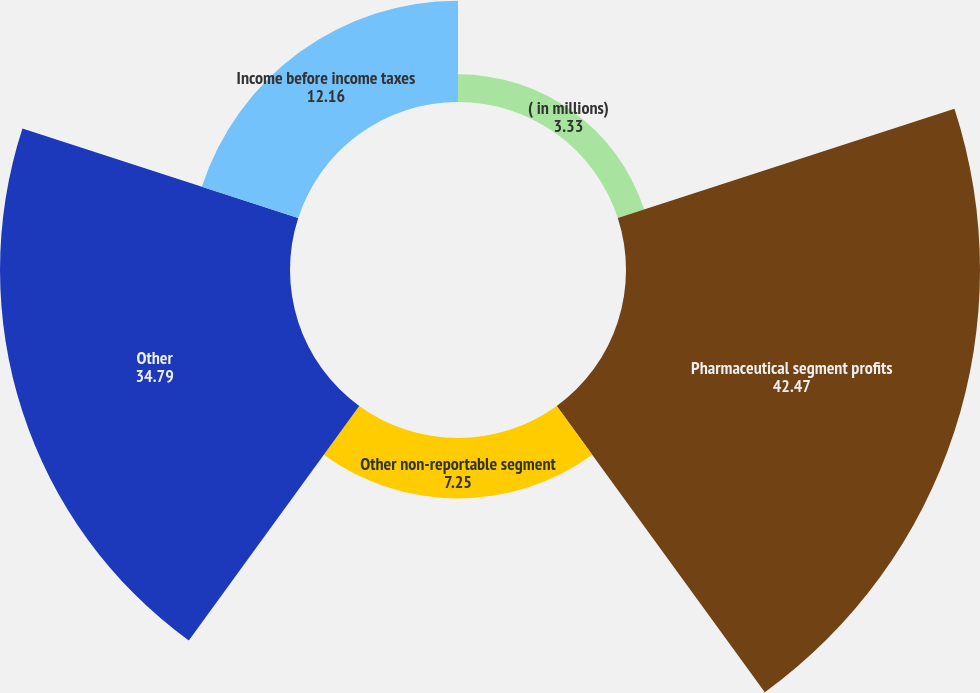Convert chart to OTSL. <chart><loc_0><loc_0><loc_500><loc_500><pie_chart><fcel>( in millions)<fcel>Pharmaceutical segment profits<fcel>Other non-reportable segment<fcel>Other<fcel>Income before income taxes<nl><fcel>3.33%<fcel>42.47%<fcel>7.25%<fcel>34.79%<fcel>12.16%<nl></chart> 